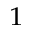<formula> <loc_0><loc_0><loc_500><loc_500>_ { 1 }</formula> 